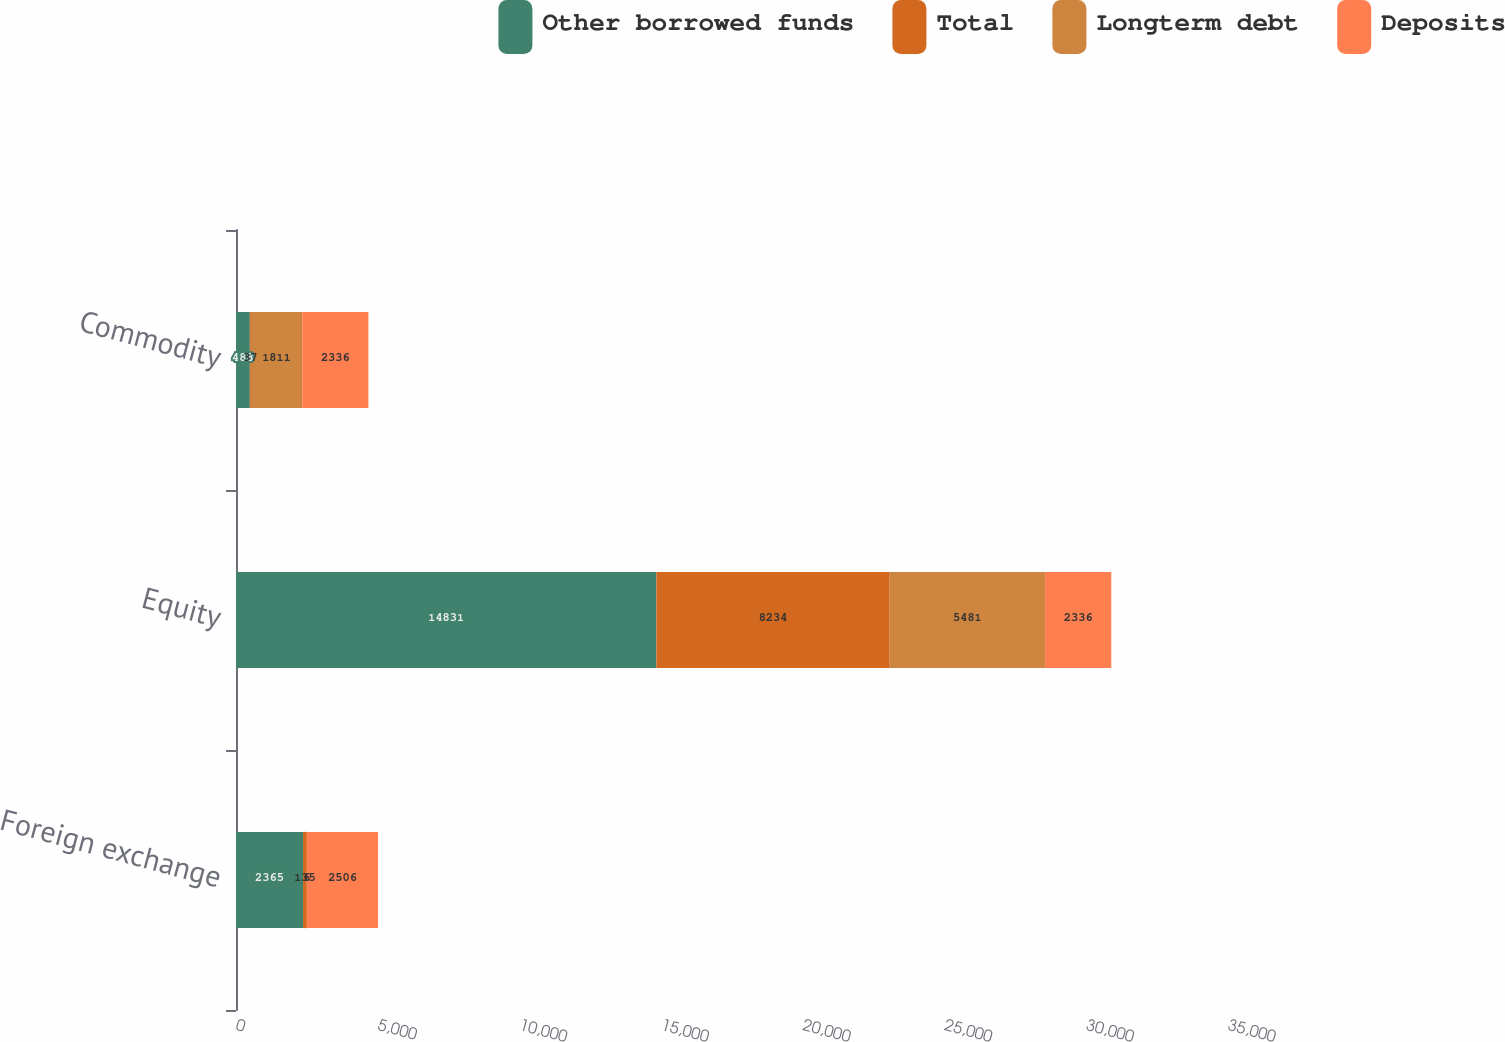Convert chart. <chart><loc_0><loc_0><loc_500><loc_500><stacked_bar_chart><ecel><fcel>Foreign exchange<fcel>Equity<fcel>Commodity<nl><fcel>Other borrowed funds<fcel>2365<fcel>14831<fcel>488<nl><fcel>Total<fcel>135<fcel>8234<fcel>37<nl><fcel>Longterm debt<fcel>6<fcel>5481<fcel>1811<nl><fcel>Deposits<fcel>2506<fcel>2336<fcel>2336<nl></chart> 